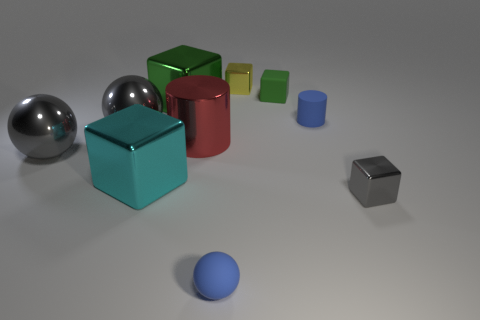Subtract all small blue spheres. How many spheres are left? 2 Subtract all red cylinders. How many cylinders are left? 1 Subtract 1 balls. How many balls are left? 2 Subtract all cylinders. How many objects are left? 8 Add 9 tiny green rubber blocks. How many tiny green rubber blocks are left? 10 Add 5 tiny blue rubber spheres. How many tiny blue rubber spheres exist? 6 Subtract 1 cyan blocks. How many objects are left? 9 Subtract all green cylinders. Subtract all brown cubes. How many cylinders are left? 2 Subtract all blue balls. How many gray cubes are left? 1 Subtract all gray shiny blocks. Subtract all cyan objects. How many objects are left? 8 